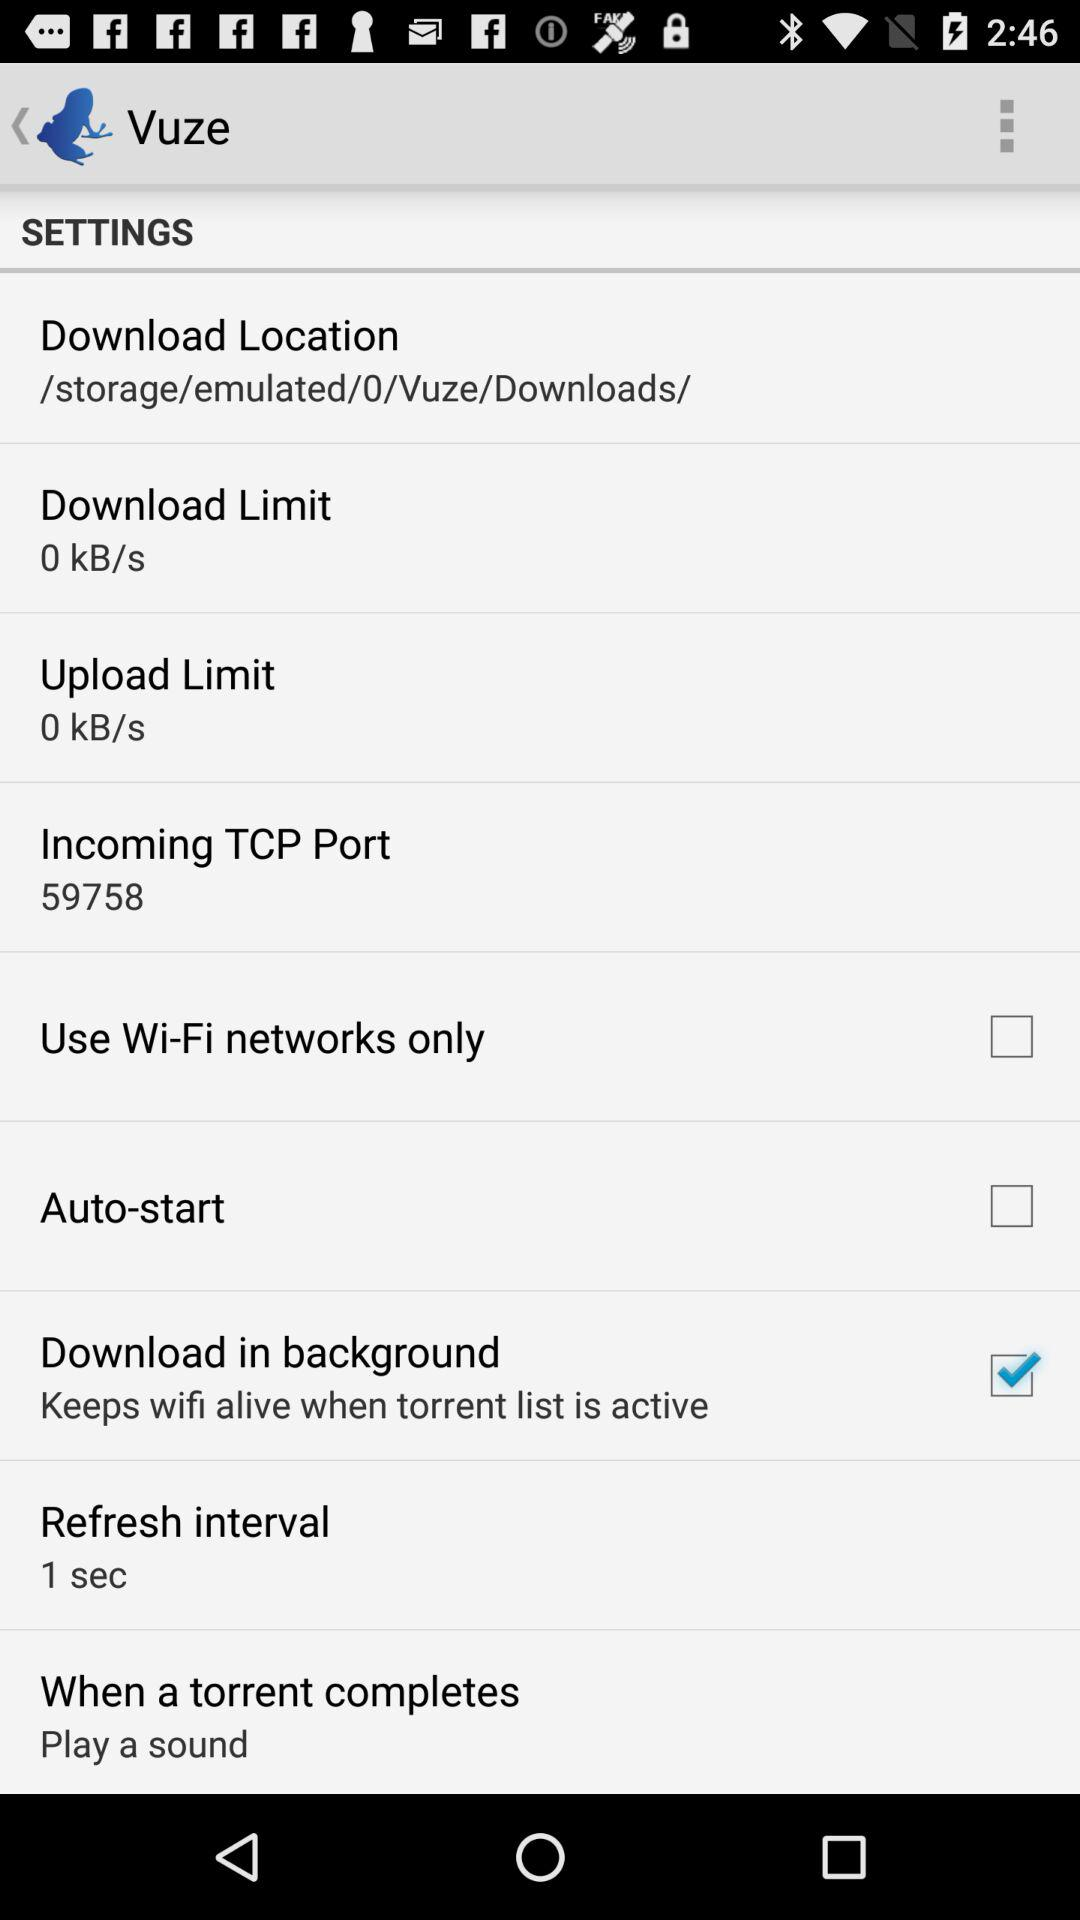Which setting is selected in "When a torrent completes"? The selected setting is "Play a sound". 